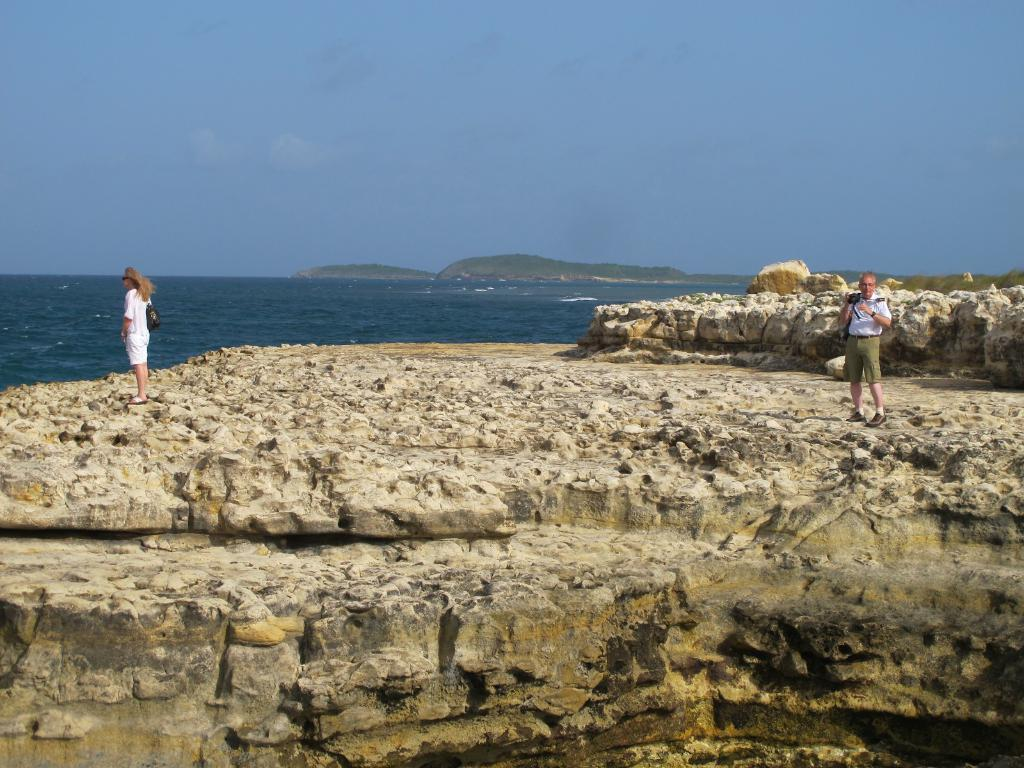What type of natural elements can be seen in the image? There are rocks in the image. How many people are present in the image? There are two persons in the image. What is the man on the right side of the image doing? The man is holding a camera in the image. What can be seen in the distance in the background of the image? There is water, hills, and the sky visible in the background of the image. How many pizzas are being served on the rocks in the image? There are no pizzas present in the image; it features rocks, two persons, a man holding a camera, water, hills, and the sky in the background. What type of ring is the woman wearing on her finger in the image? There is no ring visible on any person's finger in the image. 